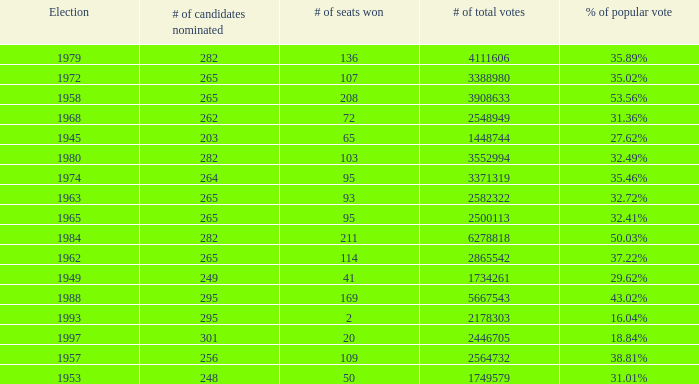What was the lowest # of total votes? 1448744.0. 